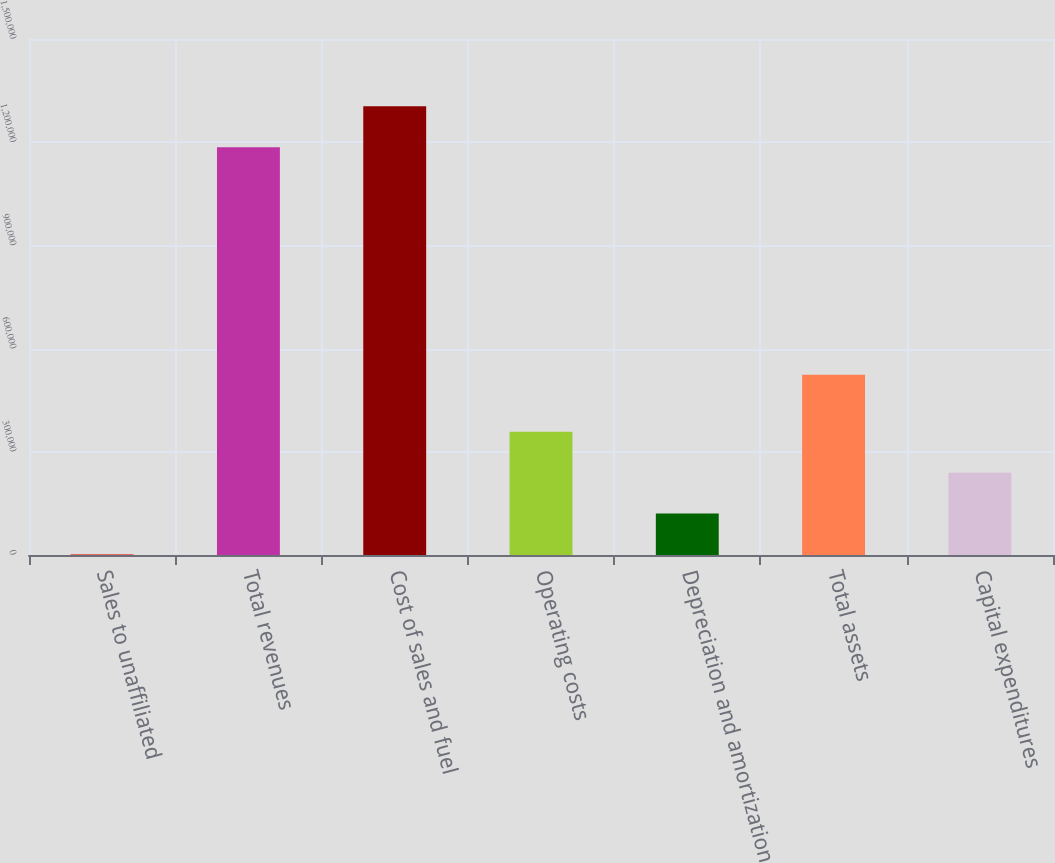<chart> <loc_0><loc_0><loc_500><loc_500><bar_chart><fcel>Sales to unaffiliated<fcel>Total revenues<fcel>Cost of sales and fuel<fcel>Operating costs<fcel>Depreciation and amortization<fcel>Total assets<fcel>Capital expenditures<nl><fcel>2475<fcel>1.18566e+06<fcel>1.30415e+06<fcel>357939<fcel>120963<fcel>523806<fcel>239451<nl></chart> 